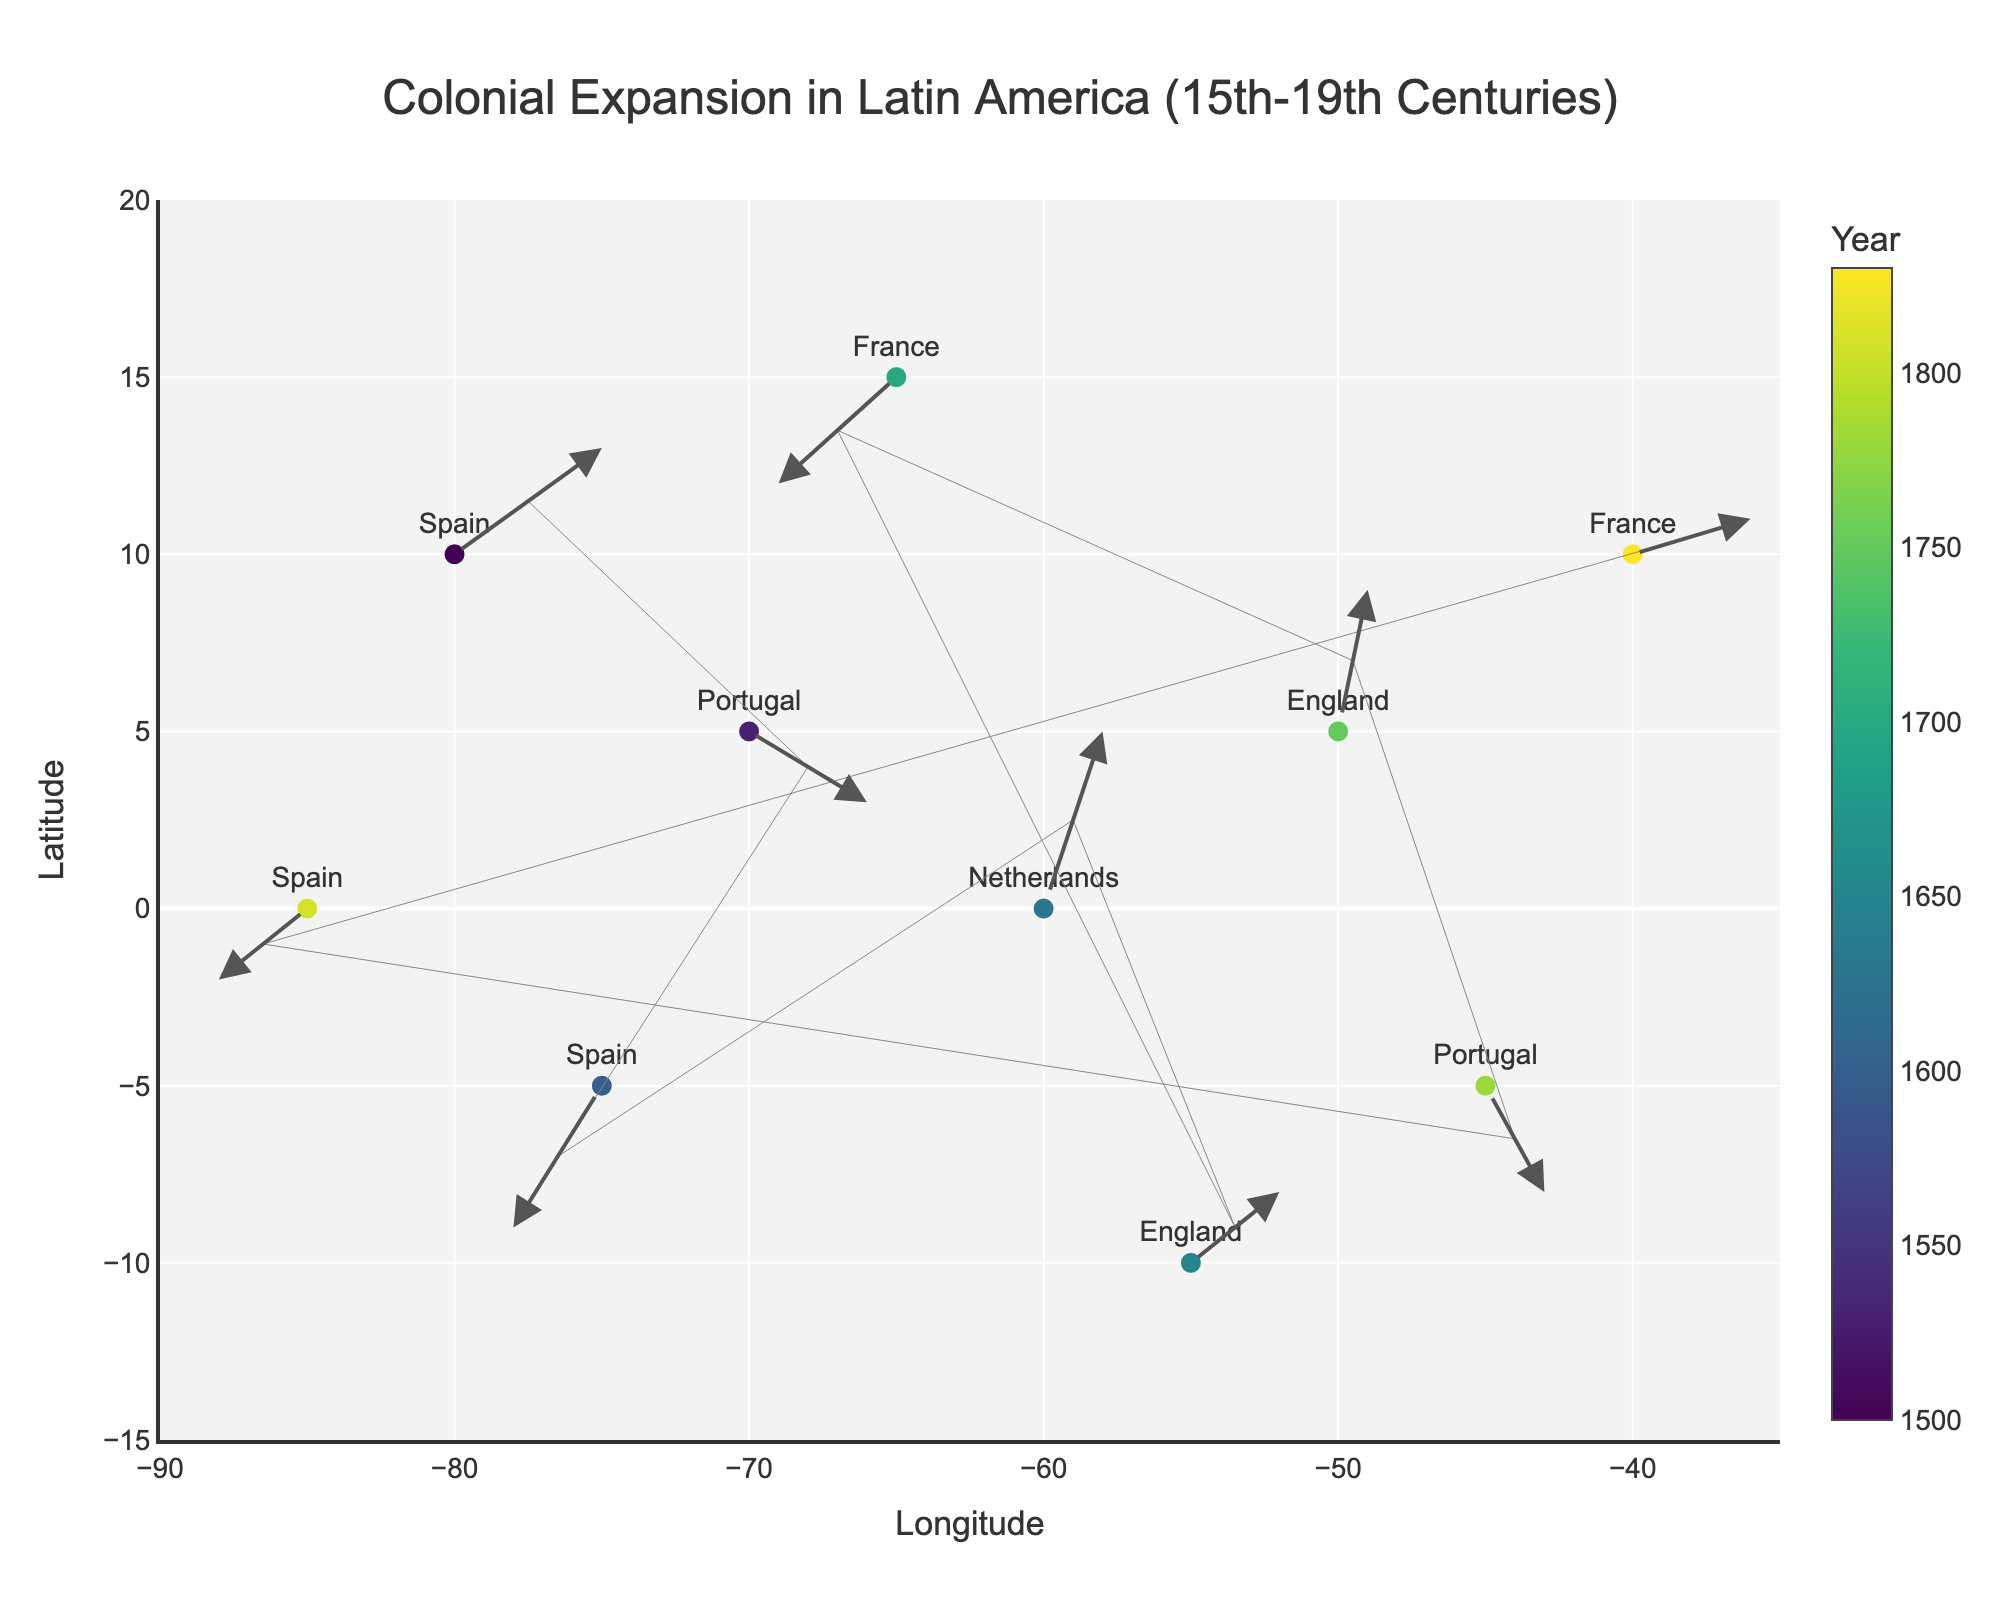What's the title of the plot? The title of the plot is located at the top of the figure. It states the main subject and time period of the data visualization.
Answer: Colonial Expansion in Latin America (15th-19th Centuries) What does the color of the markers represent? The color of the markers represents different years. This information is indicated by the colorbar on the right side of the plot.
Answer: Years Which country has a marker at the coordinates (-80, 10)? By examining the figure, the text near the coordinates (-80, 10) identifies which country is present at that location.
Answer: Spain Which two countries show movement in the positive x-direction? To answer this, observe the arrows starting from each marker and identify which arrows point to the right (positive x-direction).
Answer: Netherlands and France How many countries have arrows pointing in the negative y-direction? Arrows pointing in the negative y-direction will point downwards on the plot. Count how many such arrows exist.
Answer: Three Which country had a territorial change in both the x and y directions in 1530? By looking at the vector starting at 1530 on the colorbar, find the country connected to that vector. Use the x and y label to confirm.
Answer: Portugal What is the largest movement (in magnitude) shown on the plot? Calculate the magnitude of each vector using the formula sqrt(u^2 + v^2), and identify the largest value.
Answer: Spain in 1600 What is the longitude and latitude range of the plot? This can be determined by looking at the x-axis and y-axis tick labels, which denote the range.
Answer: Longitude range: -90 to -35, Latitude range: -15 to 20 Which country’s movement is represented by the longest arrow? The longest arrow corresponds to the largest vector magnitude. By identifying the arrow visually and comparing lengths, establish the connected country.
Answer: Spain in 1600 Between the years 1750 and 1780, which country's influence moved southwards? Examine the vectors in the plot that have colors corresponding to the years 1750 and 1780, and check the y-direction of these movements.
Answer: Portugal 